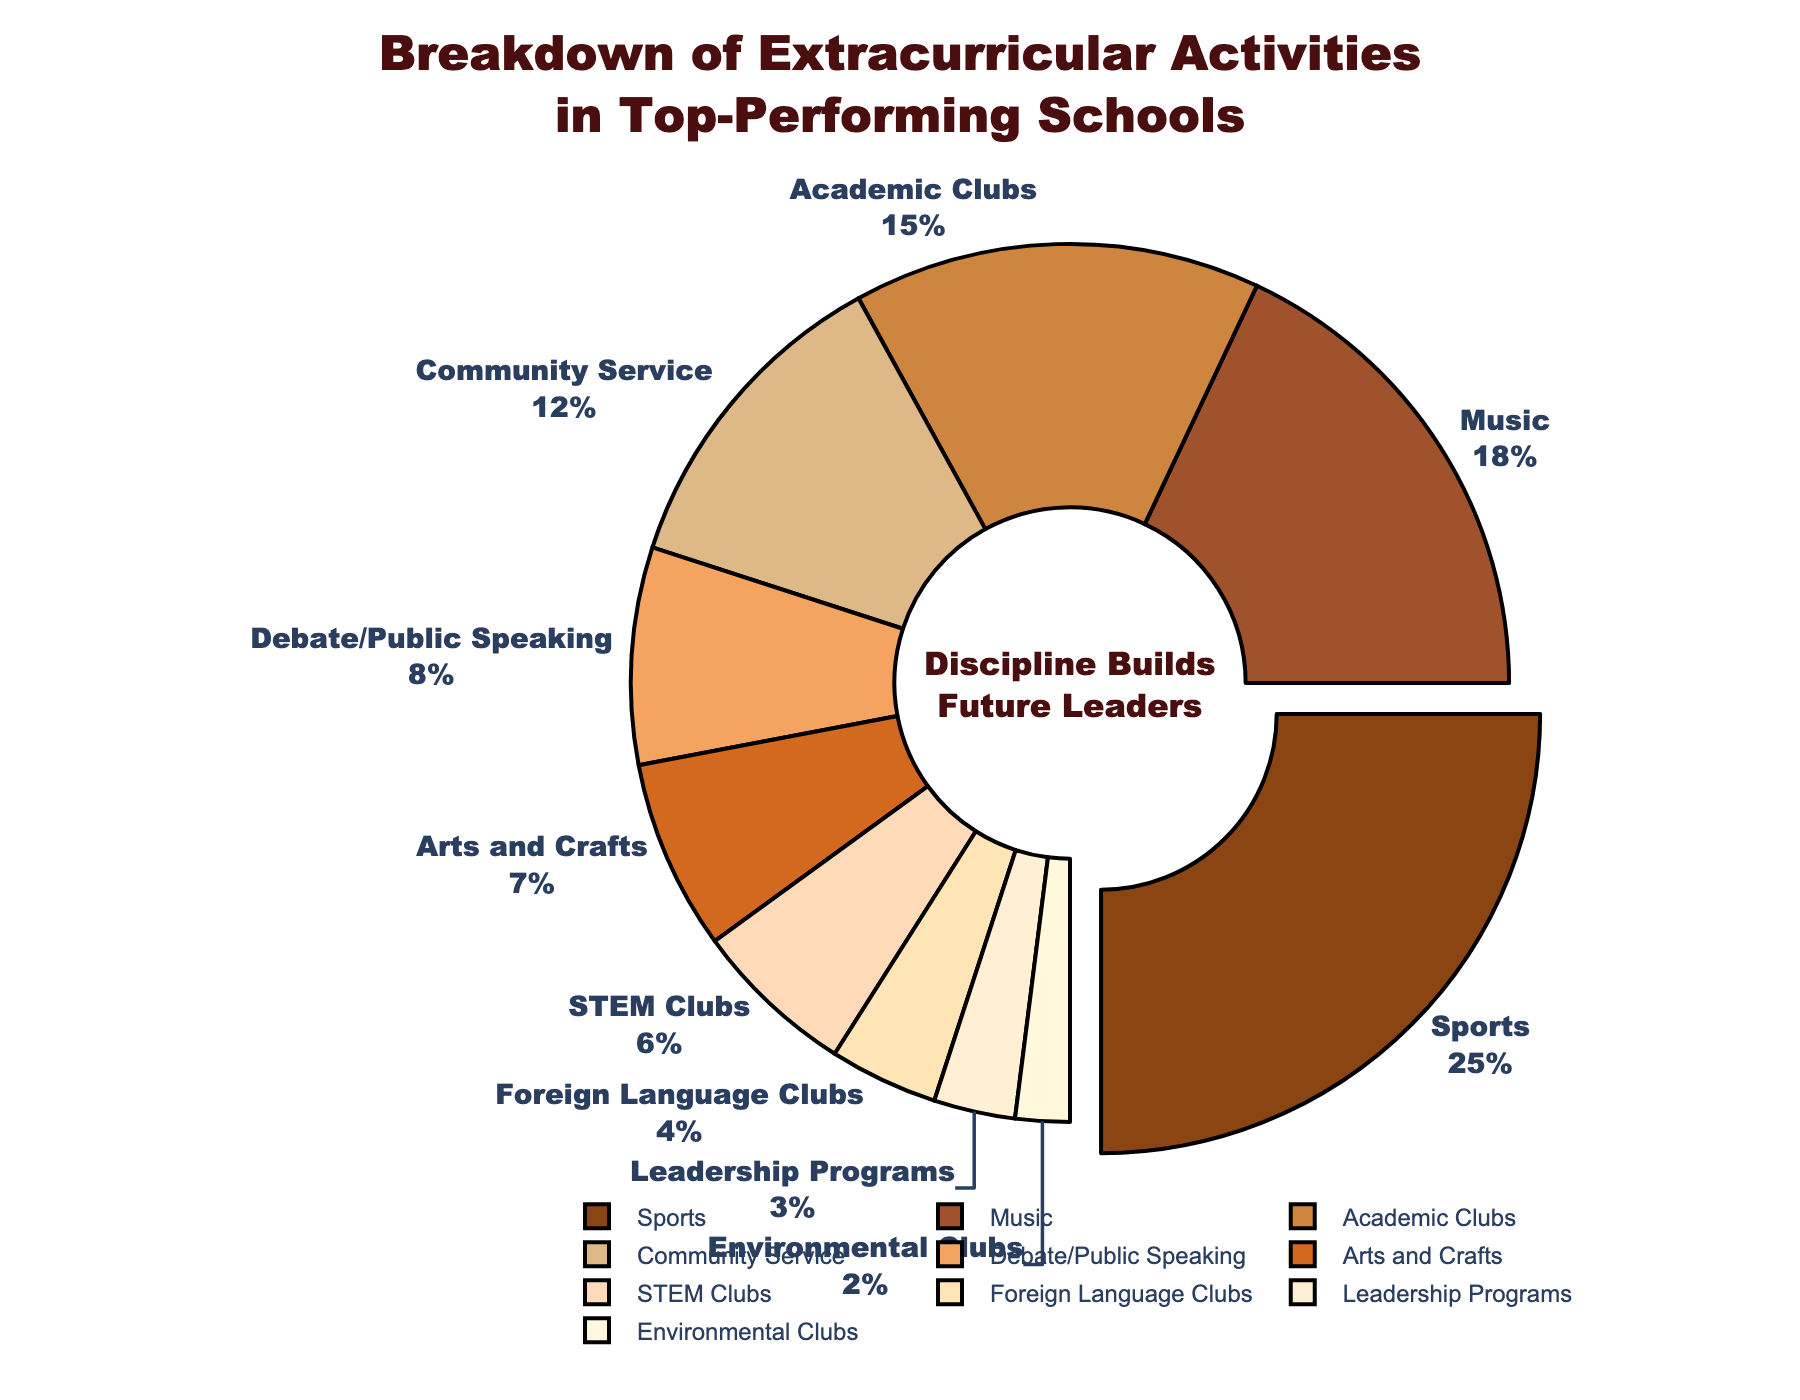What's the largest category of extracurricular activities? The pie chart pulls out the segment representing the largest category, which is Sports. It shows both the label "Sports" and its percentage, 25%.
Answer: Sports What percentage of the activities are related to arts and crafts? The pie chart has a segment labeled "Arts and Crafts," which shows its percentage to be 7%.
Answer: 7% How does the percentage for STEM Clubs compare to Debate/Public Speaking? By observing the chart, the percentage for STEM Clubs is 6%, whereas Debate/Public Speaking is 8%. 8% is greater than 6%.
Answer: Debate/Public Speaking is greater by 2% Which activity category is just below 10%? The pie chart shows that Debate/Public Speaking has a percentage of 8%, which is just below 10%.
Answer: Debate/Public Speaking Are there more activities involving Music or Academic Clubs? The pie chart shows Music has a 18% share while Academic Clubs have a 15% share. Therefore, there are more activities involving Music.
Answer: Music What's the combined percentage for Community Service and Environmental Clubs? The pie chart indicates Community Service at 12% and Environmental Clubs at 2%. Adding them together gives 12% + 2% = 14%.
Answer: 14% Do Foreign Language Clubs have a higher percentage than Leadership Programs? The pie chart shows Foreign Language Clubs at 4%, which is higher than Leadership Programs at 3%.
Answer: Yes What is the percentage difference between Sports and Foreign Language Clubs? The pie chart shows Sports at 25% and Foreign Language Clubs at 4%. The difference is 25% - 4% = 21%.
Answer: 21% What activities make up less than 5% each? By checking the pie chart, Foreign Language Clubs with 4%, Leadership Programs with 3%, and Environmental Clubs with 2% are all less than 5%.
Answer: Foreign Language Clubs, Leadership Programs, Environmental Clubs Which activity types combined make up more than 30%? By observing the chart, summing up percentages of Sports (25%), Music (18%), Community Service (12%) gives 25% + 18% + 12% = 55%, which is greater than 30%.
Answer: Sports, Music, Community Service 